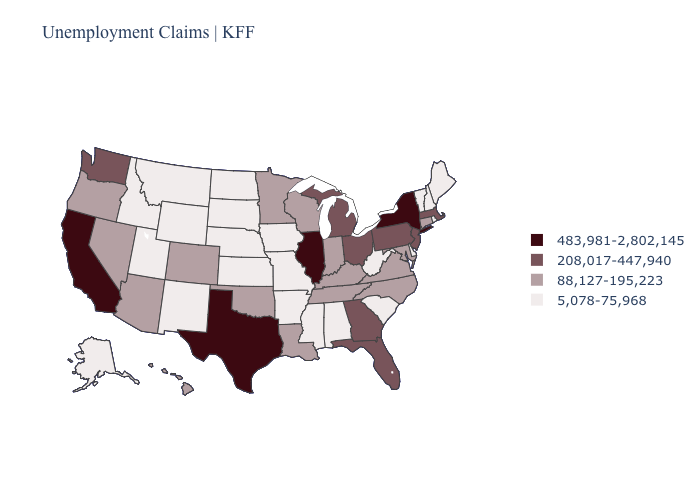What is the value of Texas?
Keep it brief. 483,981-2,802,145. Among the states that border Michigan , which have the highest value?
Answer briefly. Ohio. Does the first symbol in the legend represent the smallest category?
Concise answer only. No. What is the lowest value in states that border Missouri?
Be succinct. 5,078-75,968. Which states have the lowest value in the USA?
Concise answer only. Alabama, Alaska, Arkansas, Delaware, Idaho, Iowa, Kansas, Maine, Mississippi, Missouri, Montana, Nebraska, New Hampshire, New Mexico, North Dakota, Rhode Island, South Carolina, South Dakota, Utah, Vermont, West Virginia, Wyoming. Does Illinois have the highest value in the MidWest?
Answer briefly. Yes. What is the value of Massachusetts?
Concise answer only. 208,017-447,940. What is the highest value in the USA?
Short answer required. 483,981-2,802,145. What is the lowest value in the USA?
Write a very short answer. 5,078-75,968. Name the states that have a value in the range 88,127-195,223?
Quick response, please. Arizona, Colorado, Connecticut, Hawaii, Indiana, Kentucky, Louisiana, Maryland, Minnesota, Nevada, North Carolina, Oklahoma, Oregon, Tennessee, Virginia, Wisconsin. What is the value of Oregon?
Concise answer only. 88,127-195,223. Name the states that have a value in the range 5,078-75,968?
Keep it brief. Alabama, Alaska, Arkansas, Delaware, Idaho, Iowa, Kansas, Maine, Mississippi, Missouri, Montana, Nebraska, New Hampshire, New Mexico, North Dakota, Rhode Island, South Carolina, South Dakota, Utah, Vermont, West Virginia, Wyoming. What is the value of Virginia?
Be succinct. 88,127-195,223. Does Maryland have a higher value than Virginia?
Be succinct. No. Does Virginia have the same value as Maine?
Quick response, please. No. 